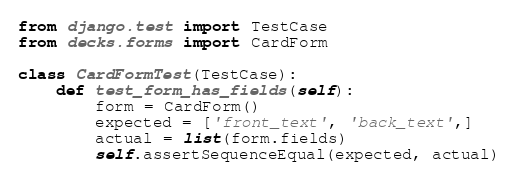Convert code to text. <code><loc_0><loc_0><loc_500><loc_500><_Python_>from django.test import TestCase
from decks.forms import CardForm

class CardFormTest(TestCase):
    def test_form_has_fields(self):
        form = CardForm()
        expected = ['front_text', 'back_text',]
        actual = list(form.fields)
        self.assertSequenceEqual(expected, actual)
</code> 